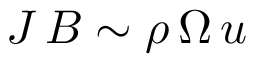Convert formula to latex. <formula><loc_0><loc_0><loc_500><loc_500>J \, B \sim \rho \, \Omega \, u</formula> 